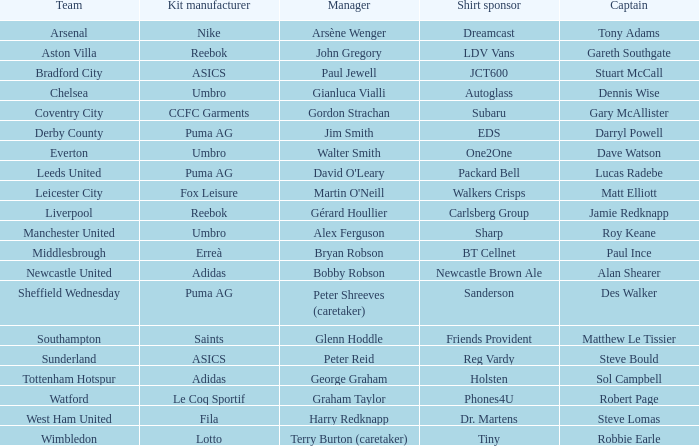Which captain is managed by gianluca vialli? Dennis Wise. 